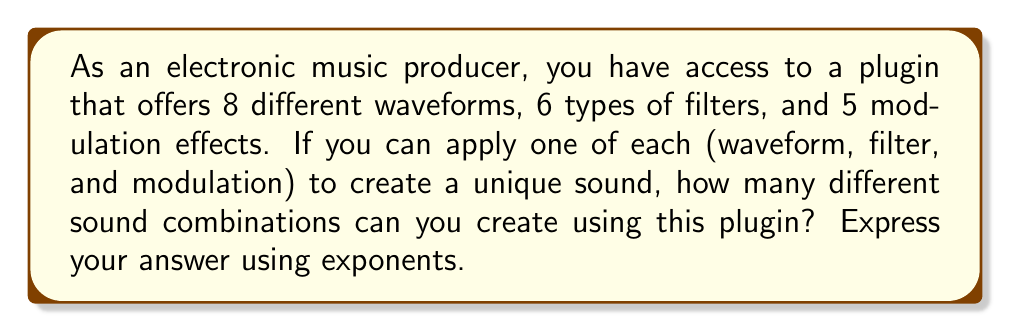Give your solution to this math problem. To solve this problem, we need to use the multiplication principle of counting and express it using exponents. Let's break it down step-by-step:

1. We have three categories of sound manipulations:
   - 8 waveforms
   - 6 filters
   - 5 modulation effects

2. For each unique sound, we choose one option from each category. This means we multiply the number of options in each category:

   $$ \text{Total combinations} = 8 \times 6 \times 5 $$

3. We can express this using exponents by considering each number as having an exponent of 1:

   $$ \text{Total combinations} = 8^1 \times 6^1 \times 5^1 $$

4. Using the properties of exponents, when multiplying terms with the same base, we add the exponents. In this case, we don't have the same base, so we leave the expression as is.

5. Calculate the result:

   $$ 8^1 \times 6^1 \times 5^1 = 8 \times 6 \times 5 = 240 $$

Therefore, you can create 240 unique sound combinations using this plugin.
Answer: $8^1 \times 6^1 \times 5^1 = 240$ unique sound combinations 